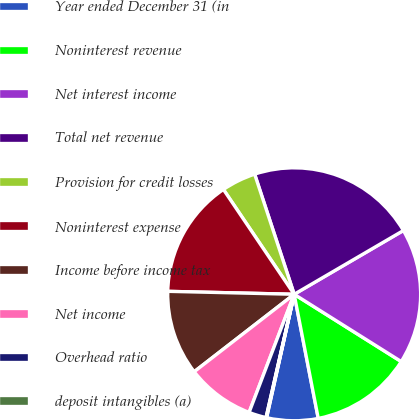Convert chart to OTSL. <chart><loc_0><loc_0><loc_500><loc_500><pie_chart><fcel>Year ended December 31 (in<fcel>Noninterest revenue<fcel>Net interest income<fcel>Total net revenue<fcel>Provision for credit losses<fcel>Noninterest expense<fcel>Income before income tax<fcel>Net income<fcel>Overhead ratio<fcel>deposit intangibles (a)<nl><fcel>6.55%<fcel>13.02%<fcel>17.34%<fcel>21.65%<fcel>4.39%<fcel>15.18%<fcel>10.86%<fcel>8.71%<fcel>2.23%<fcel>0.07%<nl></chart> 